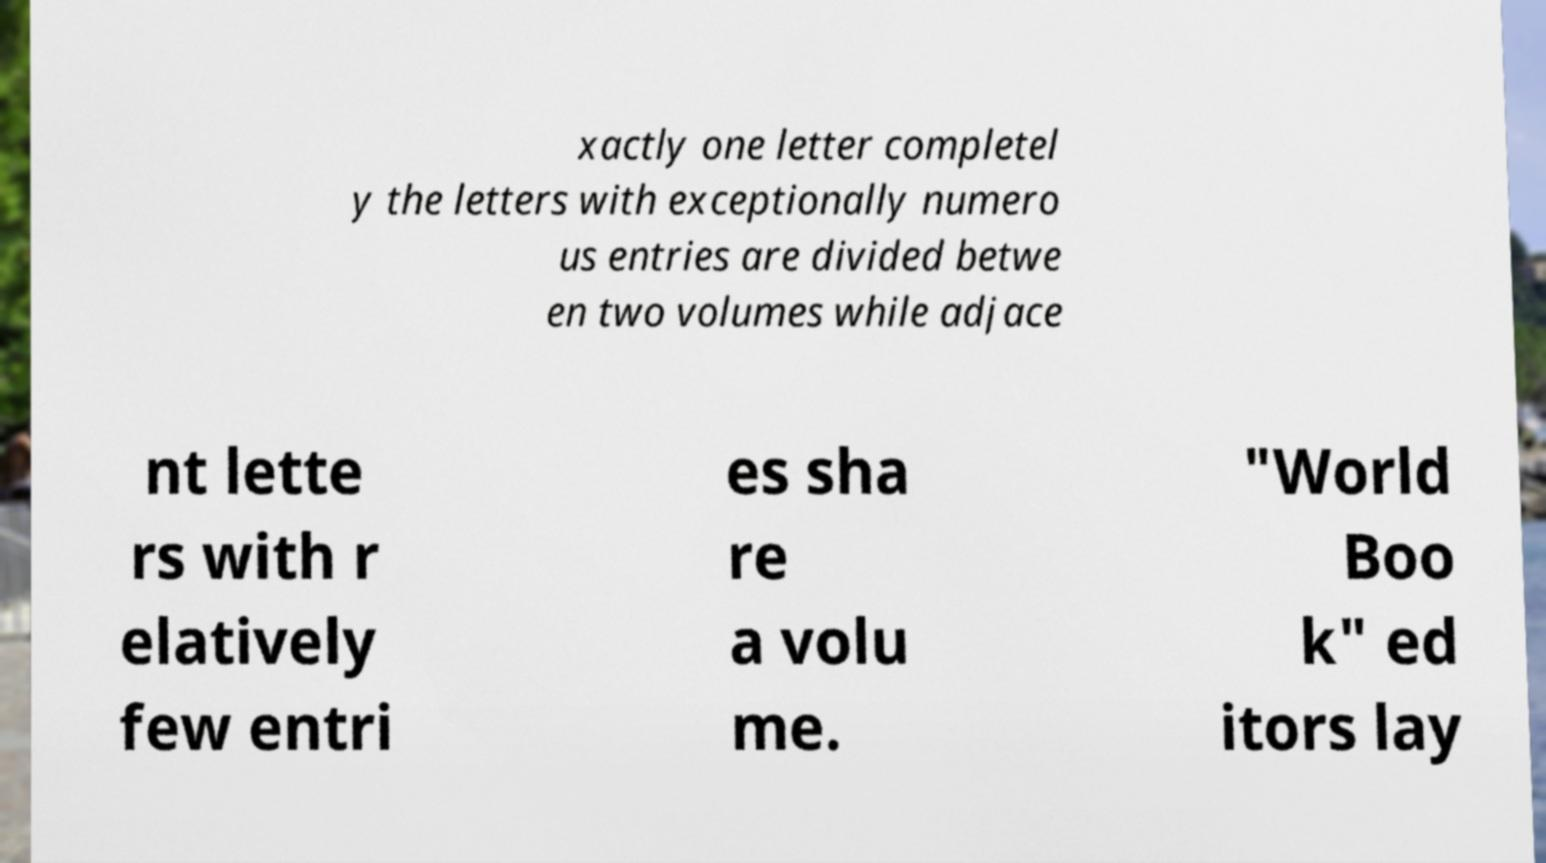Could you assist in decoding the text presented in this image and type it out clearly? xactly one letter completel y the letters with exceptionally numero us entries are divided betwe en two volumes while adjace nt lette rs with r elatively few entri es sha re a volu me. "World Boo k" ed itors lay 